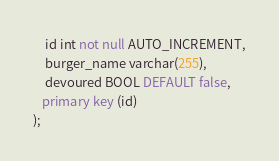<code> <loc_0><loc_0><loc_500><loc_500><_SQL_>    id int not null AUTO_INCREMENT,
    burger_name varchar(255),
    devoured BOOL DEFAULT false,
   primary key (id)
);

</code> 